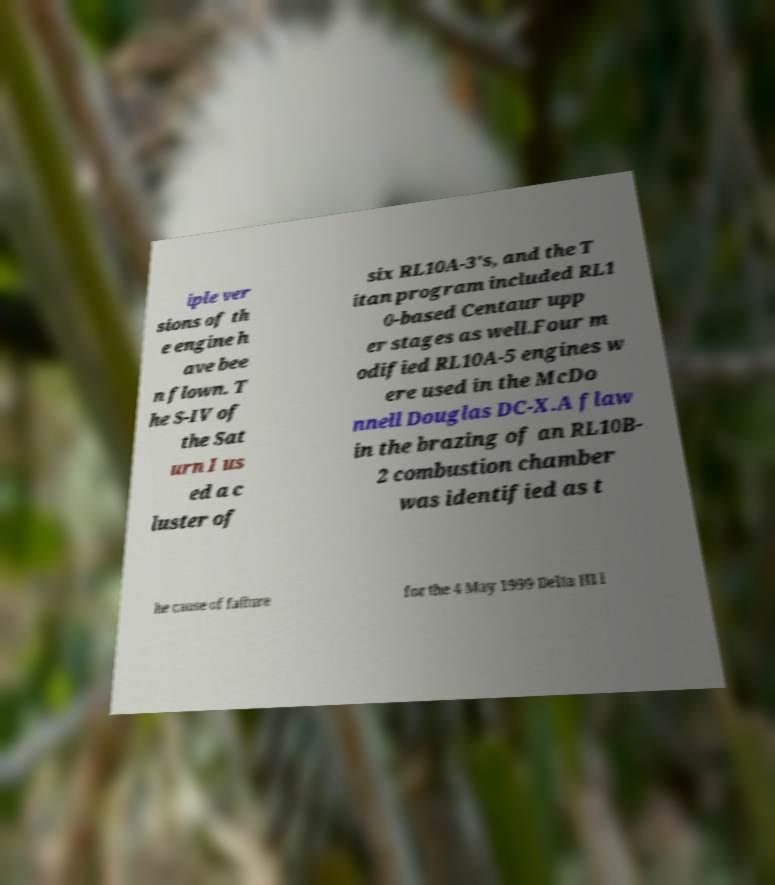There's text embedded in this image that I need extracted. Can you transcribe it verbatim? iple ver sions of th e engine h ave bee n flown. T he S-IV of the Sat urn I us ed a c luster of six RL10A-3's, and the T itan program included RL1 0-based Centaur upp er stages as well.Four m odified RL10A-5 engines w ere used in the McDo nnell Douglas DC-X.A flaw in the brazing of an RL10B- 2 combustion chamber was identified as t he cause of failure for the 4 May 1999 Delta III l 